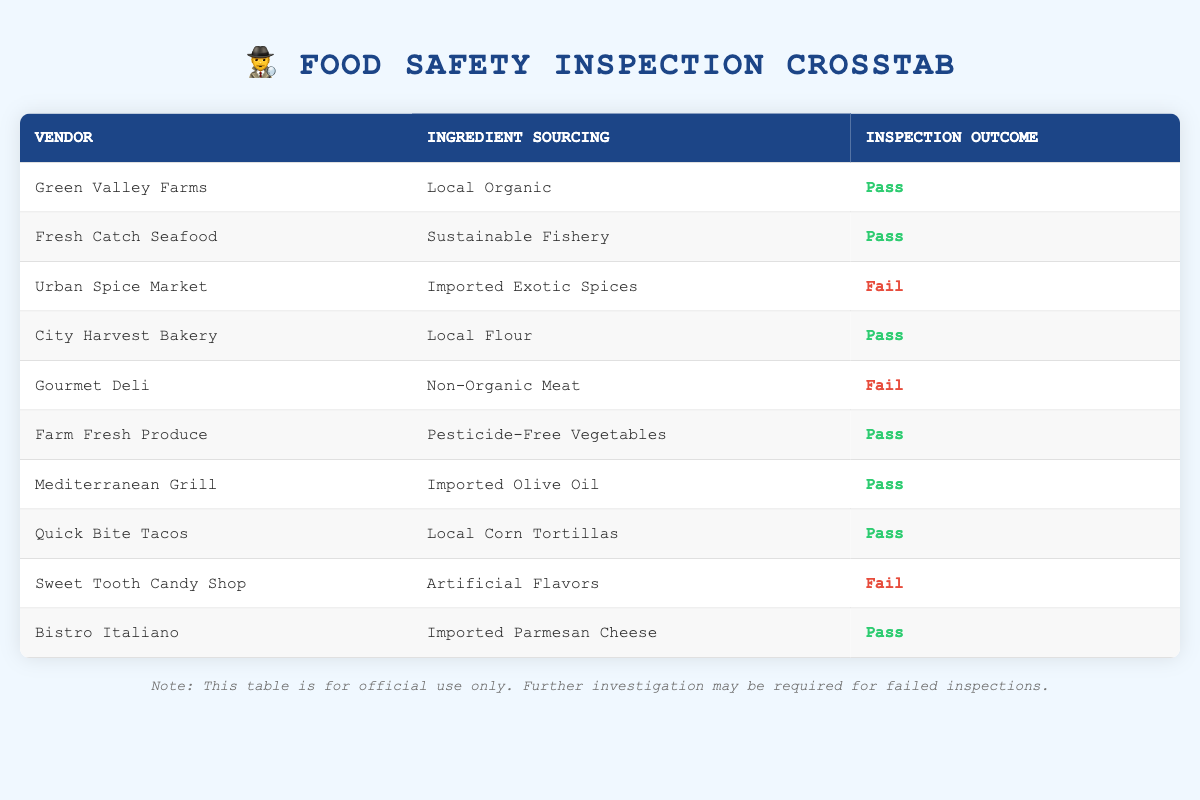What is the inspection outcome for Green Valley Farms? By looking at the row corresponding to Green Valley Farms in the table, we see that the inspection outcome is marked as "Pass."
Answer: Pass Which vendor sourced ingredients that resulted in a failed inspection? From the table, we can identify that Urban Spice Market, Gourmet Deli, and Sweet Tooth Candy Shop all have "Fail" listed under the inspection outcome.
Answer: Urban Spice Market, Gourmet Deli, Sweet Tooth Candy Shop How many vendors passed their inspections? We count the number of rows where the inspection outcome is "Pass." There are 7 vendors that passed their inspections.
Answer: 7 Is it true that all vendors sourcing from local sources passed their inspections? We observe the vendors sourcing locally: Green Valley Farms, City Harvest Bakery, and Quick Bite Tacos, all of which have "Pass" as the inspection outcome. Therefore, it is true.
Answer: Yes What percentage of vendors sourced ingredients that are labeled "Fail"? Out of the 10 total vendors, 3 have a "Fail" inspection. The percentage is calculated as (3/10)*100 = 30%.
Answer: 30% How do the inspection outcomes differ between locally sourced and imported ingredients? From the table, we find that all vendors with locally sourced ingredients have passed, while the vendors sourcing imported ingredients have mixed outcomes, with Mediterranean Grill passing and Urban Spice Market failing.
Answer: Locally sourced passed; imports mixed What is the difference in the number of failed inspections between vendors with organic versus non-organic ingredients? Vendors with organic sourcing (Green Valley Farms, Farm Fresh Produce) both passed, while vendors with non-organic (Gourmet Deli) failed. Thus, the difference is 0 failed organic versus 1 failed non-organic.
Answer: 1 How many vendors did not use artificial flavors and passed their inspections? We review the table and find out of 10 vendors, all except Sweet Tooth Candy Shop (which used artificial flavors) passed. Therefore, 8 vendors did not use artificial flavors and passed.
Answer: 8 What are the inspection outcomes for vendors using imported ingredients? In the table, we see that Urban Spice Market (Fail), imported Olive Oil (Pass), and imported Parmesan Cheese (Pass) are three examples. Therefore, the outcomes are mixed: one fail and two passes.
Answer: Mixed outcomes: 1 Fail, 2 Passes 